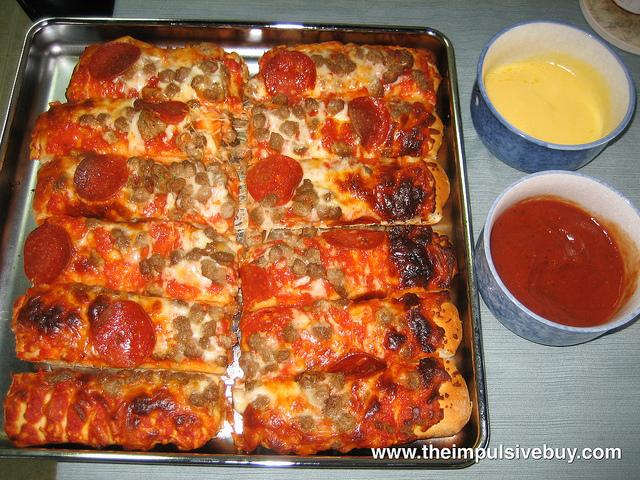Is this the way pizza is normally shaped?
Concise answer only. No. What is in the picture?
Write a very short answer. Pizza. What sauces are shown?
Quick response, please. Ketchup mustard. 